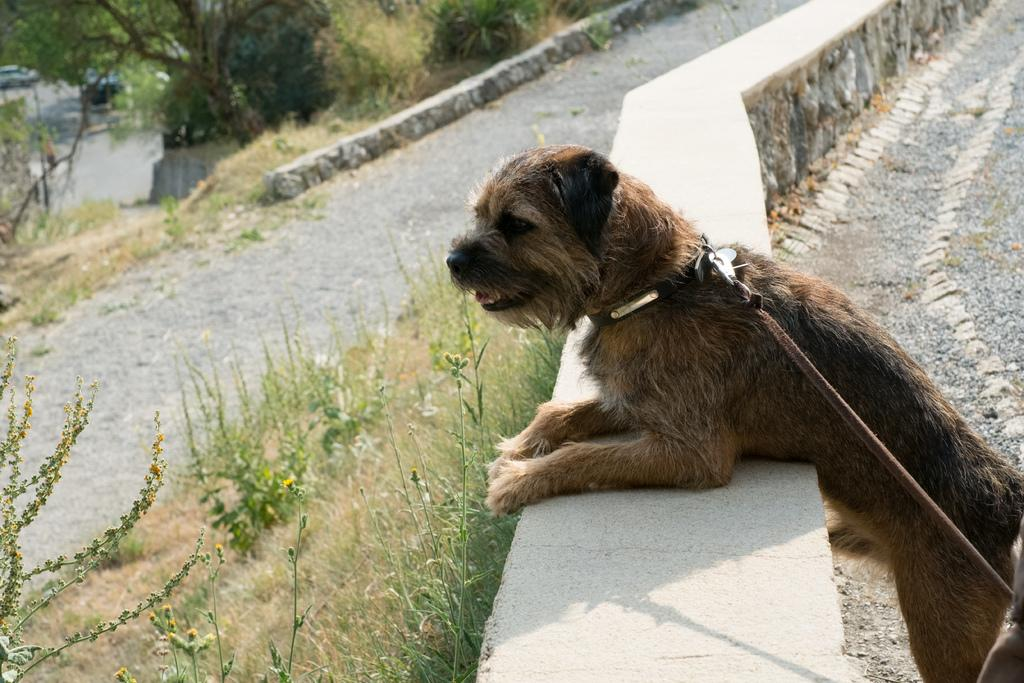What type of animal is in the image? There is a dog in the image. What is the dog wearing? The dog is wearing a belt. On which side of the image is the dog located? The dog is on the right side of the image. What type of pathway is in the image? There is a road in the image. On which side of the image is the road located? The road is on the left side of the image. What type of vegetation is in the image? There are plants and a tree in the image. What type of marble is the dog playing with in the image? There is no marble present in the image; the dog is wearing a belt. What type of plate is the tree growing out of in the image? There is no plate present in the image; the tree is growing independently. 